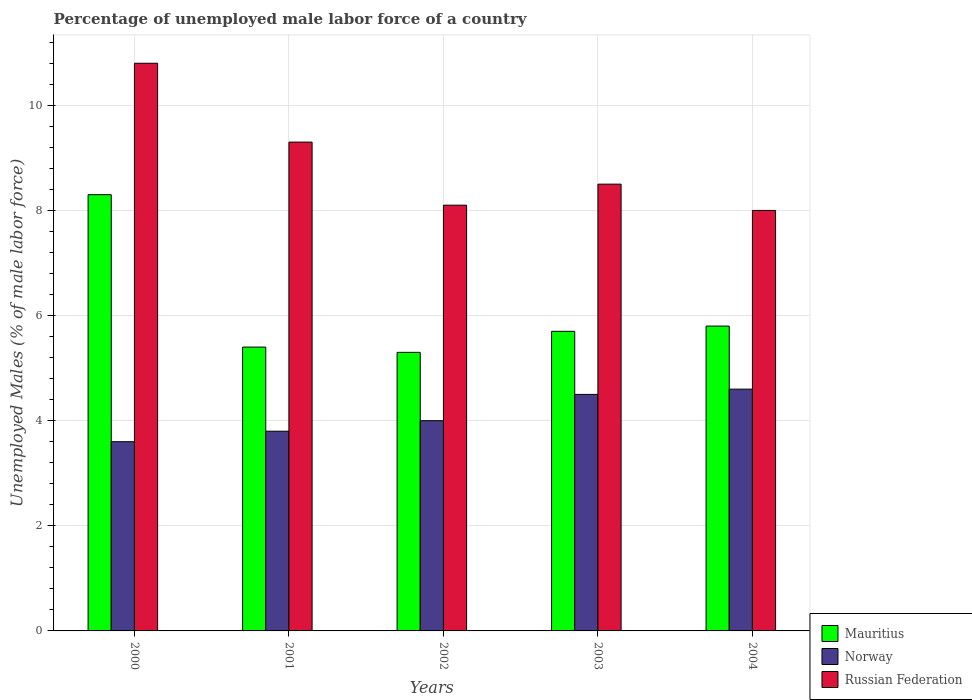How many groups of bars are there?
Give a very brief answer. 5. How many bars are there on the 3rd tick from the left?
Your response must be concise. 3. How many bars are there on the 5th tick from the right?
Offer a terse response. 3. In how many cases, is the number of bars for a given year not equal to the number of legend labels?
Keep it short and to the point. 0. What is the percentage of unemployed male labor force in Norway in 2000?
Your answer should be very brief. 3.6. Across all years, what is the maximum percentage of unemployed male labor force in Norway?
Make the answer very short. 4.6. Across all years, what is the minimum percentage of unemployed male labor force in Russian Federation?
Ensure brevity in your answer.  8. In which year was the percentage of unemployed male labor force in Russian Federation maximum?
Offer a terse response. 2000. In which year was the percentage of unemployed male labor force in Mauritius minimum?
Ensure brevity in your answer.  2002. What is the total percentage of unemployed male labor force in Norway in the graph?
Keep it short and to the point. 20.5. What is the difference between the percentage of unemployed male labor force in Russian Federation in 2001 and that in 2003?
Your answer should be compact. 0.8. What is the difference between the percentage of unemployed male labor force in Norway in 2000 and the percentage of unemployed male labor force in Mauritius in 2004?
Offer a very short reply. -2.2. What is the average percentage of unemployed male labor force in Russian Federation per year?
Your response must be concise. 8.94. In the year 2002, what is the difference between the percentage of unemployed male labor force in Norway and percentage of unemployed male labor force in Mauritius?
Keep it short and to the point. -1.3. What is the ratio of the percentage of unemployed male labor force in Mauritius in 2000 to that in 2004?
Give a very brief answer. 1.43. Is the difference between the percentage of unemployed male labor force in Norway in 2001 and 2002 greater than the difference between the percentage of unemployed male labor force in Mauritius in 2001 and 2002?
Your answer should be very brief. No. What is the difference between the highest and the second highest percentage of unemployed male labor force in Russian Federation?
Make the answer very short. 1.5. What is the difference between the highest and the lowest percentage of unemployed male labor force in Mauritius?
Your answer should be compact. 3. What does the 3rd bar from the left in 2003 represents?
Provide a short and direct response. Russian Federation. Where does the legend appear in the graph?
Your response must be concise. Bottom right. How many legend labels are there?
Provide a succinct answer. 3. What is the title of the graph?
Offer a very short reply. Percentage of unemployed male labor force of a country. What is the label or title of the Y-axis?
Ensure brevity in your answer.  Unemployed Males (% of male labor force). What is the Unemployed Males (% of male labor force) of Mauritius in 2000?
Give a very brief answer. 8.3. What is the Unemployed Males (% of male labor force) of Norway in 2000?
Your answer should be compact. 3.6. What is the Unemployed Males (% of male labor force) in Russian Federation in 2000?
Ensure brevity in your answer.  10.8. What is the Unemployed Males (% of male labor force) of Mauritius in 2001?
Ensure brevity in your answer.  5.4. What is the Unemployed Males (% of male labor force) in Norway in 2001?
Ensure brevity in your answer.  3.8. What is the Unemployed Males (% of male labor force) of Russian Federation in 2001?
Keep it short and to the point. 9.3. What is the Unemployed Males (% of male labor force) in Mauritius in 2002?
Keep it short and to the point. 5.3. What is the Unemployed Males (% of male labor force) of Norway in 2002?
Your answer should be very brief. 4. What is the Unemployed Males (% of male labor force) of Russian Federation in 2002?
Your answer should be compact. 8.1. What is the Unemployed Males (% of male labor force) in Mauritius in 2003?
Provide a short and direct response. 5.7. What is the Unemployed Males (% of male labor force) of Norway in 2003?
Provide a short and direct response. 4.5. What is the Unemployed Males (% of male labor force) of Russian Federation in 2003?
Your answer should be very brief. 8.5. What is the Unemployed Males (% of male labor force) in Mauritius in 2004?
Provide a short and direct response. 5.8. What is the Unemployed Males (% of male labor force) in Norway in 2004?
Offer a terse response. 4.6. What is the Unemployed Males (% of male labor force) of Russian Federation in 2004?
Your answer should be very brief. 8. Across all years, what is the maximum Unemployed Males (% of male labor force) of Mauritius?
Your answer should be compact. 8.3. Across all years, what is the maximum Unemployed Males (% of male labor force) of Norway?
Offer a terse response. 4.6. Across all years, what is the maximum Unemployed Males (% of male labor force) in Russian Federation?
Provide a succinct answer. 10.8. Across all years, what is the minimum Unemployed Males (% of male labor force) of Mauritius?
Make the answer very short. 5.3. Across all years, what is the minimum Unemployed Males (% of male labor force) in Norway?
Give a very brief answer. 3.6. What is the total Unemployed Males (% of male labor force) of Mauritius in the graph?
Ensure brevity in your answer.  30.5. What is the total Unemployed Males (% of male labor force) in Russian Federation in the graph?
Keep it short and to the point. 44.7. What is the difference between the Unemployed Males (% of male labor force) in Russian Federation in 2000 and that in 2001?
Your answer should be very brief. 1.5. What is the difference between the Unemployed Males (% of male labor force) of Mauritius in 2000 and that in 2002?
Your answer should be compact. 3. What is the difference between the Unemployed Males (% of male labor force) of Mauritius in 2000 and that in 2003?
Keep it short and to the point. 2.6. What is the difference between the Unemployed Males (% of male labor force) of Norway in 2000 and that in 2003?
Make the answer very short. -0.9. What is the difference between the Unemployed Males (% of male labor force) in Russian Federation in 2000 and that in 2003?
Your answer should be compact. 2.3. What is the difference between the Unemployed Males (% of male labor force) in Mauritius in 2000 and that in 2004?
Give a very brief answer. 2.5. What is the difference between the Unemployed Males (% of male labor force) of Russian Federation in 2000 and that in 2004?
Keep it short and to the point. 2.8. What is the difference between the Unemployed Males (% of male labor force) in Russian Federation in 2001 and that in 2002?
Keep it short and to the point. 1.2. What is the difference between the Unemployed Males (% of male labor force) of Mauritius in 2001 and that in 2003?
Make the answer very short. -0.3. What is the difference between the Unemployed Males (% of male labor force) of Norway in 2001 and that in 2003?
Give a very brief answer. -0.7. What is the difference between the Unemployed Males (% of male labor force) in Russian Federation in 2001 and that in 2003?
Make the answer very short. 0.8. What is the difference between the Unemployed Males (% of male labor force) of Mauritius in 2001 and that in 2004?
Offer a terse response. -0.4. What is the difference between the Unemployed Males (% of male labor force) in Norway in 2001 and that in 2004?
Your response must be concise. -0.8. What is the difference between the Unemployed Males (% of male labor force) in Russian Federation in 2001 and that in 2004?
Provide a short and direct response. 1.3. What is the difference between the Unemployed Males (% of male labor force) of Mauritius in 2002 and that in 2003?
Ensure brevity in your answer.  -0.4. What is the difference between the Unemployed Males (% of male labor force) of Norway in 2002 and that in 2003?
Offer a very short reply. -0.5. What is the difference between the Unemployed Males (% of male labor force) of Mauritius in 2002 and that in 2004?
Make the answer very short. -0.5. What is the difference between the Unemployed Males (% of male labor force) of Russian Federation in 2002 and that in 2004?
Keep it short and to the point. 0.1. What is the difference between the Unemployed Males (% of male labor force) of Norway in 2003 and that in 2004?
Make the answer very short. -0.1. What is the difference between the Unemployed Males (% of male labor force) in Russian Federation in 2003 and that in 2004?
Keep it short and to the point. 0.5. What is the difference between the Unemployed Males (% of male labor force) of Mauritius in 2000 and the Unemployed Males (% of male labor force) of Norway in 2001?
Make the answer very short. 4.5. What is the difference between the Unemployed Males (% of male labor force) of Mauritius in 2000 and the Unemployed Males (% of male labor force) of Russian Federation in 2001?
Provide a short and direct response. -1. What is the difference between the Unemployed Males (% of male labor force) in Mauritius in 2000 and the Unemployed Males (% of male labor force) in Norway in 2002?
Ensure brevity in your answer.  4.3. What is the difference between the Unemployed Males (% of male labor force) of Mauritius in 2000 and the Unemployed Males (% of male labor force) of Russian Federation in 2002?
Provide a succinct answer. 0.2. What is the difference between the Unemployed Males (% of male labor force) in Norway in 2000 and the Unemployed Males (% of male labor force) in Russian Federation in 2002?
Your answer should be compact. -4.5. What is the difference between the Unemployed Males (% of male labor force) of Mauritius in 2000 and the Unemployed Males (% of male labor force) of Norway in 2003?
Make the answer very short. 3.8. What is the difference between the Unemployed Males (% of male labor force) of Mauritius in 2000 and the Unemployed Males (% of male labor force) of Norway in 2004?
Provide a short and direct response. 3.7. What is the difference between the Unemployed Males (% of male labor force) in Norway in 2000 and the Unemployed Males (% of male labor force) in Russian Federation in 2004?
Ensure brevity in your answer.  -4.4. What is the difference between the Unemployed Males (% of male labor force) in Mauritius in 2001 and the Unemployed Males (% of male labor force) in Norway in 2002?
Your answer should be compact. 1.4. What is the difference between the Unemployed Males (% of male labor force) in Mauritius in 2001 and the Unemployed Males (% of male labor force) in Russian Federation in 2002?
Provide a succinct answer. -2.7. What is the difference between the Unemployed Males (% of male labor force) of Mauritius in 2001 and the Unemployed Males (% of male labor force) of Russian Federation in 2003?
Provide a short and direct response. -3.1. What is the difference between the Unemployed Males (% of male labor force) of Mauritius in 2001 and the Unemployed Males (% of male labor force) of Norway in 2004?
Your answer should be compact. 0.8. What is the difference between the Unemployed Males (% of male labor force) of Mauritius in 2002 and the Unemployed Males (% of male labor force) of Norway in 2003?
Keep it short and to the point. 0.8. What is the difference between the Unemployed Males (% of male labor force) in Mauritius in 2002 and the Unemployed Males (% of male labor force) in Russian Federation in 2003?
Give a very brief answer. -3.2. What is the difference between the Unemployed Males (% of male labor force) of Mauritius in 2002 and the Unemployed Males (% of male labor force) of Norway in 2004?
Your answer should be very brief. 0.7. What is the difference between the Unemployed Males (% of male labor force) of Mauritius in 2002 and the Unemployed Males (% of male labor force) of Russian Federation in 2004?
Your response must be concise. -2.7. What is the difference between the Unemployed Males (% of male labor force) of Norway in 2002 and the Unemployed Males (% of male labor force) of Russian Federation in 2004?
Provide a short and direct response. -4. What is the difference between the Unemployed Males (% of male labor force) of Mauritius in 2003 and the Unemployed Males (% of male labor force) of Russian Federation in 2004?
Your answer should be compact. -2.3. What is the average Unemployed Males (% of male labor force) in Mauritius per year?
Give a very brief answer. 6.1. What is the average Unemployed Males (% of male labor force) in Russian Federation per year?
Give a very brief answer. 8.94. In the year 2000, what is the difference between the Unemployed Males (% of male labor force) in Mauritius and Unemployed Males (% of male labor force) in Norway?
Provide a short and direct response. 4.7. In the year 2000, what is the difference between the Unemployed Males (% of male labor force) of Mauritius and Unemployed Males (% of male labor force) of Russian Federation?
Offer a very short reply. -2.5. In the year 2000, what is the difference between the Unemployed Males (% of male labor force) of Norway and Unemployed Males (% of male labor force) of Russian Federation?
Your response must be concise. -7.2. In the year 2001, what is the difference between the Unemployed Males (% of male labor force) in Mauritius and Unemployed Males (% of male labor force) in Norway?
Provide a short and direct response. 1.6. In the year 2001, what is the difference between the Unemployed Males (% of male labor force) of Norway and Unemployed Males (% of male labor force) of Russian Federation?
Provide a succinct answer. -5.5. In the year 2002, what is the difference between the Unemployed Males (% of male labor force) of Mauritius and Unemployed Males (% of male labor force) of Norway?
Your answer should be very brief. 1.3. In the year 2002, what is the difference between the Unemployed Males (% of male labor force) of Norway and Unemployed Males (% of male labor force) of Russian Federation?
Keep it short and to the point. -4.1. In the year 2003, what is the difference between the Unemployed Males (% of male labor force) in Mauritius and Unemployed Males (% of male labor force) in Norway?
Make the answer very short. 1.2. In the year 2004, what is the difference between the Unemployed Males (% of male labor force) of Mauritius and Unemployed Males (% of male labor force) of Norway?
Keep it short and to the point. 1.2. In the year 2004, what is the difference between the Unemployed Males (% of male labor force) of Mauritius and Unemployed Males (% of male labor force) of Russian Federation?
Keep it short and to the point. -2.2. In the year 2004, what is the difference between the Unemployed Males (% of male labor force) in Norway and Unemployed Males (% of male labor force) in Russian Federation?
Keep it short and to the point. -3.4. What is the ratio of the Unemployed Males (% of male labor force) of Mauritius in 2000 to that in 2001?
Your answer should be compact. 1.54. What is the ratio of the Unemployed Males (% of male labor force) in Russian Federation in 2000 to that in 2001?
Your response must be concise. 1.16. What is the ratio of the Unemployed Males (% of male labor force) in Mauritius in 2000 to that in 2002?
Ensure brevity in your answer.  1.57. What is the ratio of the Unemployed Males (% of male labor force) in Russian Federation in 2000 to that in 2002?
Your answer should be compact. 1.33. What is the ratio of the Unemployed Males (% of male labor force) in Mauritius in 2000 to that in 2003?
Your answer should be compact. 1.46. What is the ratio of the Unemployed Males (% of male labor force) in Norway in 2000 to that in 2003?
Offer a terse response. 0.8. What is the ratio of the Unemployed Males (% of male labor force) in Russian Federation in 2000 to that in 2003?
Make the answer very short. 1.27. What is the ratio of the Unemployed Males (% of male labor force) in Mauritius in 2000 to that in 2004?
Keep it short and to the point. 1.43. What is the ratio of the Unemployed Males (% of male labor force) in Norway in 2000 to that in 2004?
Provide a succinct answer. 0.78. What is the ratio of the Unemployed Males (% of male labor force) in Russian Federation in 2000 to that in 2004?
Provide a short and direct response. 1.35. What is the ratio of the Unemployed Males (% of male labor force) of Mauritius in 2001 to that in 2002?
Offer a very short reply. 1.02. What is the ratio of the Unemployed Males (% of male labor force) in Russian Federation in 2001 to that in 2002?
Give a very brief answer. 1.15. What is the ratio of the Unemployed Males (% of male labor force) in Norway in 2001 to that in 2003?
Provide a succinct answer. 0.84. What is the ratio of the Unemployed Males (% of male labor force) in Russian Federation in 2001 to that in 2003?
Give a very brief answer. 1.09. What is the ratio of the Unemployed Males (% of male labor force) of Mauritius in 2001 to that in 2004?
Offer a very short reply. 0.93. What is the ratio of the Unemployed Males (% of male labor force) in Norway in 2001 to that in 2004?
Your answer should be compact. 0.83. What is the ratio of the Unemployed Males (% of male labor force) in Russian Federation in 2001 to that in 2004?
Offer a terse response. 1.16. What is the ratio of the Unemployed Males (% of male labor force) of Mauritius in 2002 to that in 2003?
Provide a short and direct response. 0.93. What is the ratio of the Unemployed Males (% of male labor force) of Norway in 2002 to that in 2003?
Your response must be concise. 0.89. What is the ratio of the Unemployed Males (% of male labor force) of Russian Federation in 2002 to that in 2003?
Make the answer very short. 0.95. What is the ratio of the Unemployed Males (% of male labor force) in Mauritius in 2002 to that in 2004?
Offer a terse response. 0.91. What is the ratio of the Unemployed Males (% of male labor force) of Norway in 2002 to that in 2004?
Ensure brevity in your answer.  0.87. What is the ratio of the Unemployed Males (% of male labor force) of Russian Federation in 2002 to that in 2004?
Provide a succinct answer. 1.01. What is the ratio of the Unemployed Males (% of male labor force) of Mauritius in 2003 to that in 2004?
Give a very brief answer. 0.98. What is the ratio of the Unemployed Males (% of male labor force) in Norway in 2003 to that in 2004?
Make the answer very short. 0.98. What is the ratio of the Unemployed Males (% of male labor force) in Russian Federation in 2003 to that in 2004?
Offer a very short reply. 1.06. What is the difference between the highest and the second highest Unemployed Males (% of male labor force) of Mauritius?
Keep it short and to the point. 2.5. What is the difference between the highest and the second highest Unemployed Males (% of male labor force) in Norway?
Ensure brevity in your answer.  0.1. What is the difference between the highest and the lowest Unemployed Males (% of male labor force) of Norway?
Keep it short and to the point. 1. 